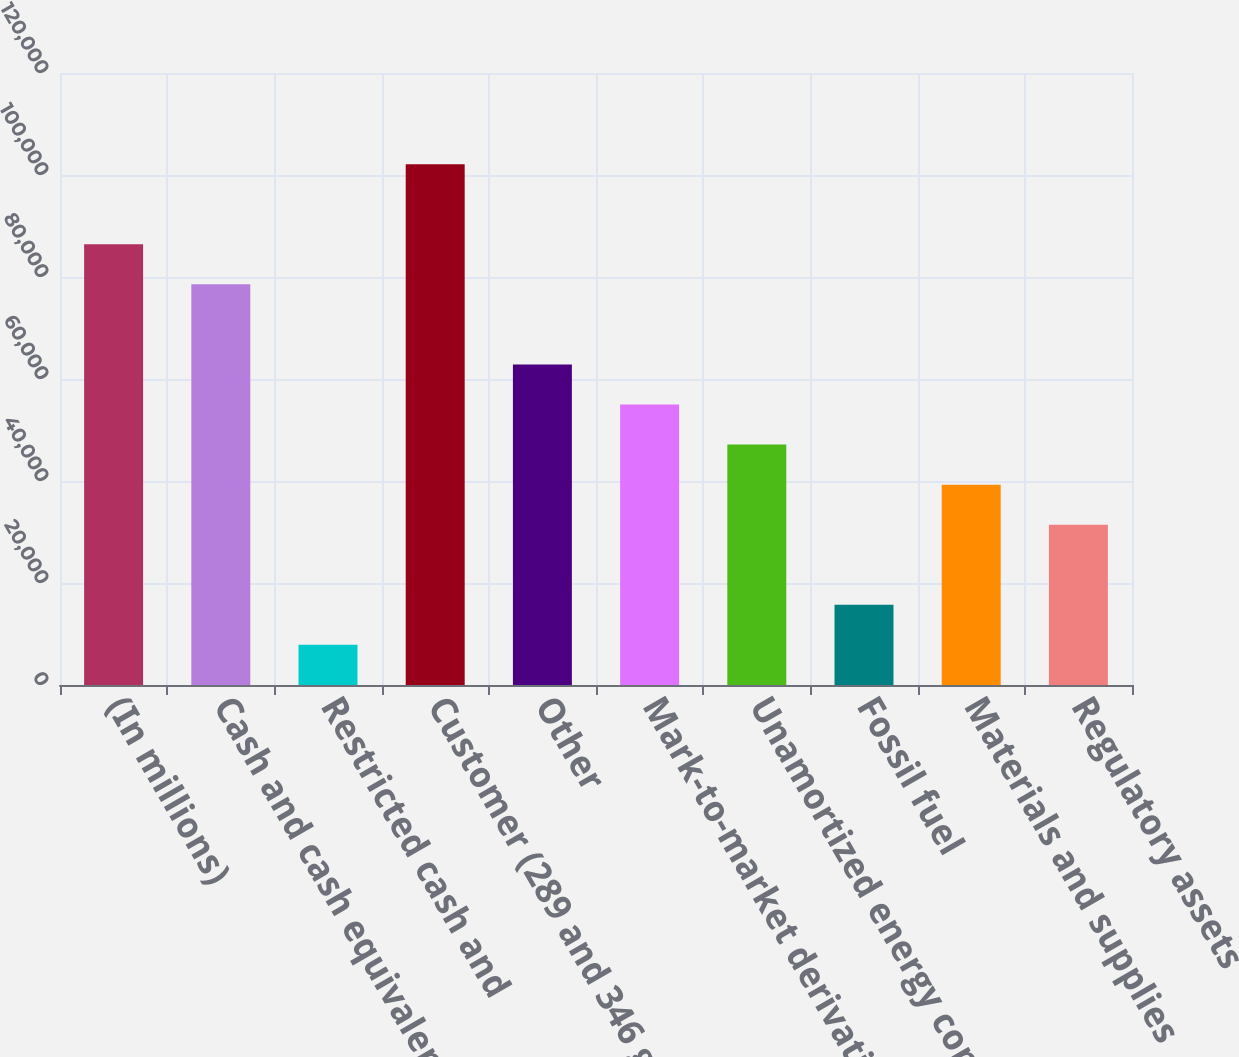Convert chart. <chart><loc_0><loc_0><loc_500><loc_500><bar_chart><fcel>(In millions)<fcel>Cash and cash equivalents<fcel>Restricted cash and<fcel>Customer (289 and 346 gross<fcel>Other<fcel>Mark-to-market derivative<fcel>Unamortized energy contract<fcel>Fossil fuel<fcel>Materials and supplies<fcel>Regulatory assets<nl><fcel>86407.2<fcel>78554<fcel>7875.2<fcel>102114<fcel>62847.6<fcel>54994.4<fcel>47141.2<fcel>15728.4<fcel>39288<fcel>31434.8<nl></chart> 